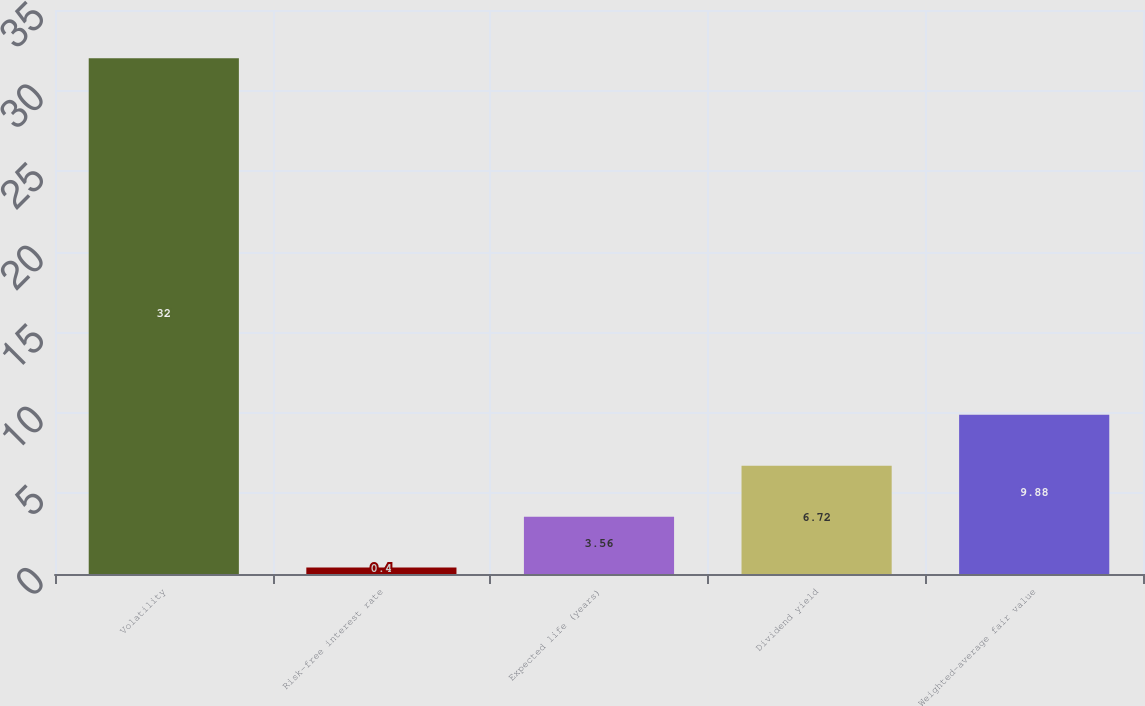Convert chart to OTSL. <chart><loc_0><loc_0><loc_500><loc_500><bar_chart><fcel>Volatility<fcel>Risk-free interest rate<fcel>Expected life (years)<fcel>Dividend yield<fcel>Weighted-average fair value<nl><fcel>32<fcel>0.4<fcel>3.56<fcel>6.72<fcel>9.88<nl></chart> 